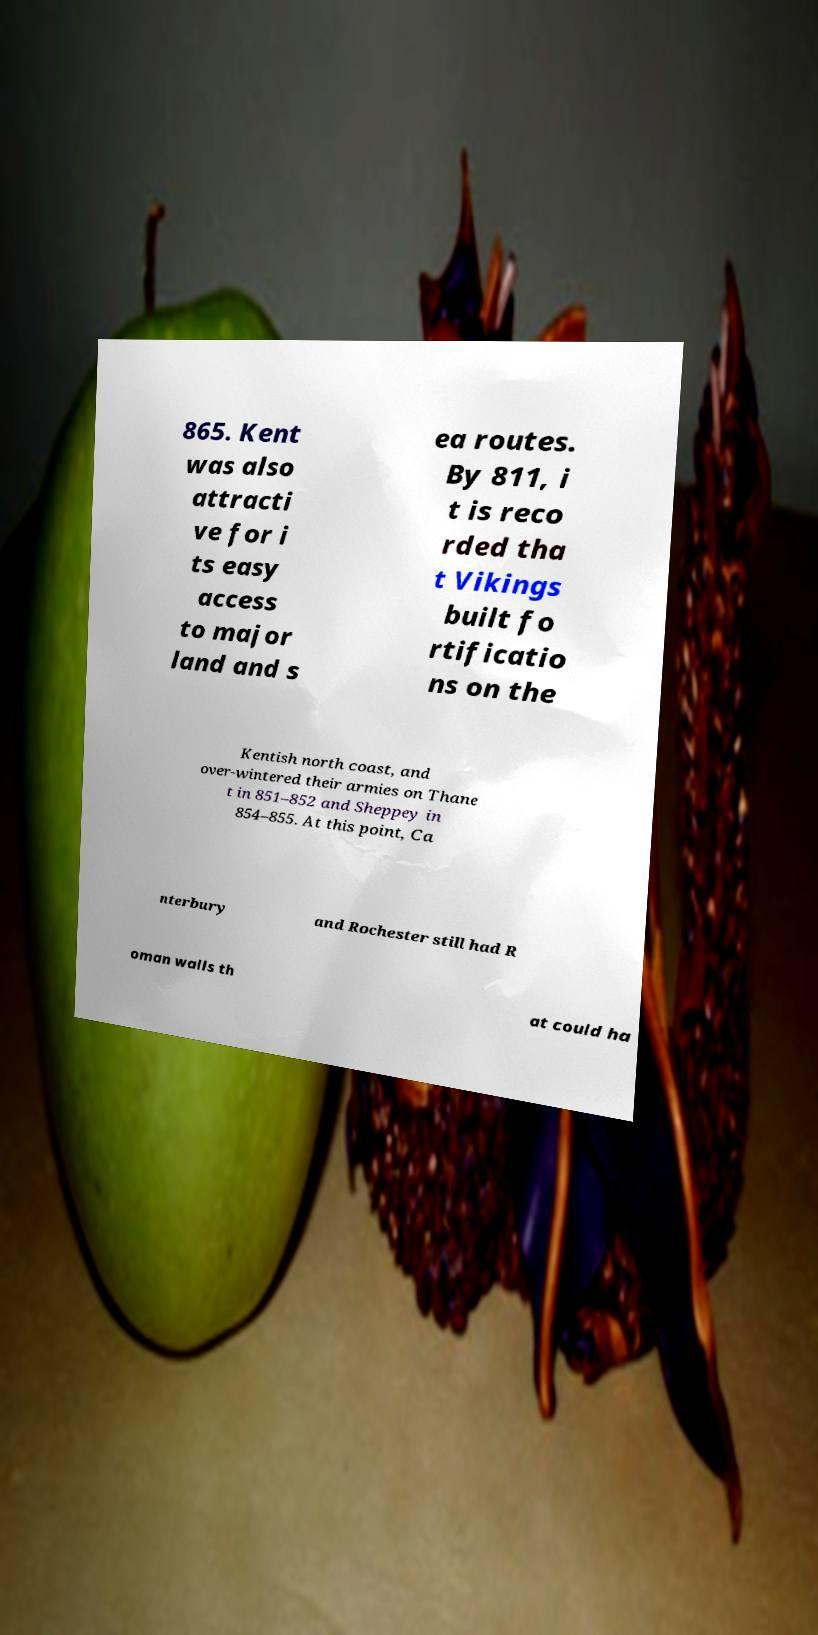Can you accurately transcribe the text from the provided image for me? 865. Kent was also attracti ve for i ts easy access to major land and s ea routes. By 811, i t is reco rded tha t Vikings built fo rtificatio ns on the Kentish north coast, and over-wintered their armies on Thane t in 851–852 and Sheppey in 854–855. At this point, Ca nterbury and Rochester still had R oman walls th at could ha 